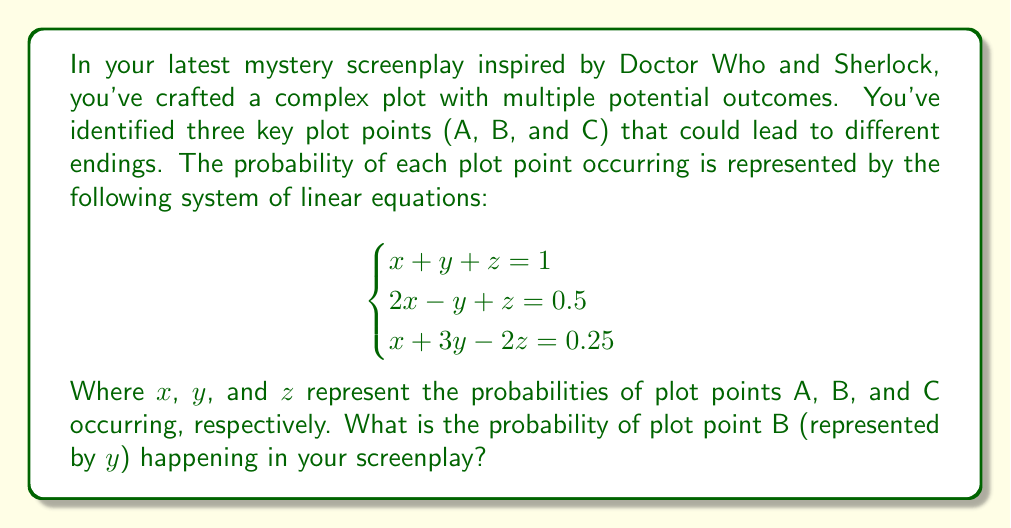Can you answer this question? To solve this system of linear equations, we'll use the elimination method:

1) First, let's eliminate $z$ by subtracting equation (1) from equation (2):
   $x - 2y = -0.5$ ... (4)

2) Now, let's eliminate $x$ by adding equation (1) to equation (3):
   $4y - z = 1.25$ ... (5)

3) Subtract equation (1) from equation (5):
   $3y - 2z = 0.25$ ... (6)

4) Now we have equations (4) and (6), which form a system with two unknowns:
   $$
   \begin{cases}
   x - 2y = -0.5 \\
   3y - 2z = 0.25
   \end{cases}
   $$

5) From equation (4): $x = 2y - 0.5$

6) Substitute this into equation (1):
   $(2y - 0.5) + y + z = 1$
   $3y + z = 1.5$ ... (7)

7) Now we have equations (6) and (7):
   $$
   \begin{cases}
   3y - 2z = 0.25 \\
   3y + z = 1.5
   \end{cases}
   $$

8) Add these equations:
   $6y - z = 1.75$

9) Subtract equation (7) from this:
   $3y - 2z = 0.25$
   
   Therefore: $3y = 1.5$

10) Solve for $y$:
    $y = 0.5$

Thus, the probability of plot point B occurring is 0.5 or 50%.
Answer: $0.5$ 